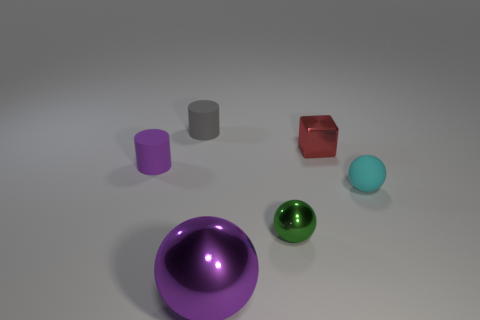What can the different colors of the objects tell us? The diverse colors might represent variety or be used to distinguish the objects from one another. In a practical sense, color-coding can aid in organization or classification in different contexts. Could these objects be representative of something greater, like a concept or theme? Potentially, the objects could symbolize diversity and individuality, as each one stands out uniquely. Alternatively, they might merely be a collection with no deeper meaning, simply showcasing different geometrical shapes and colors. 